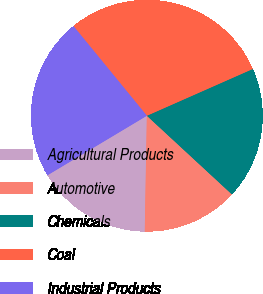Convert chart to OTSL. <chart><loc_0><loc_0><loc_500><loc_500><pie_chart><fcel>Agricultural Products<fcel>Automotive<fcel>Chemicals<fcel>Coal<fcel>Industrial Products<nl><fcel>16.13%<fcel>13.41%<fcel>18.5%<fcel>29.3%<fcel>22.67%<nl></chart> 